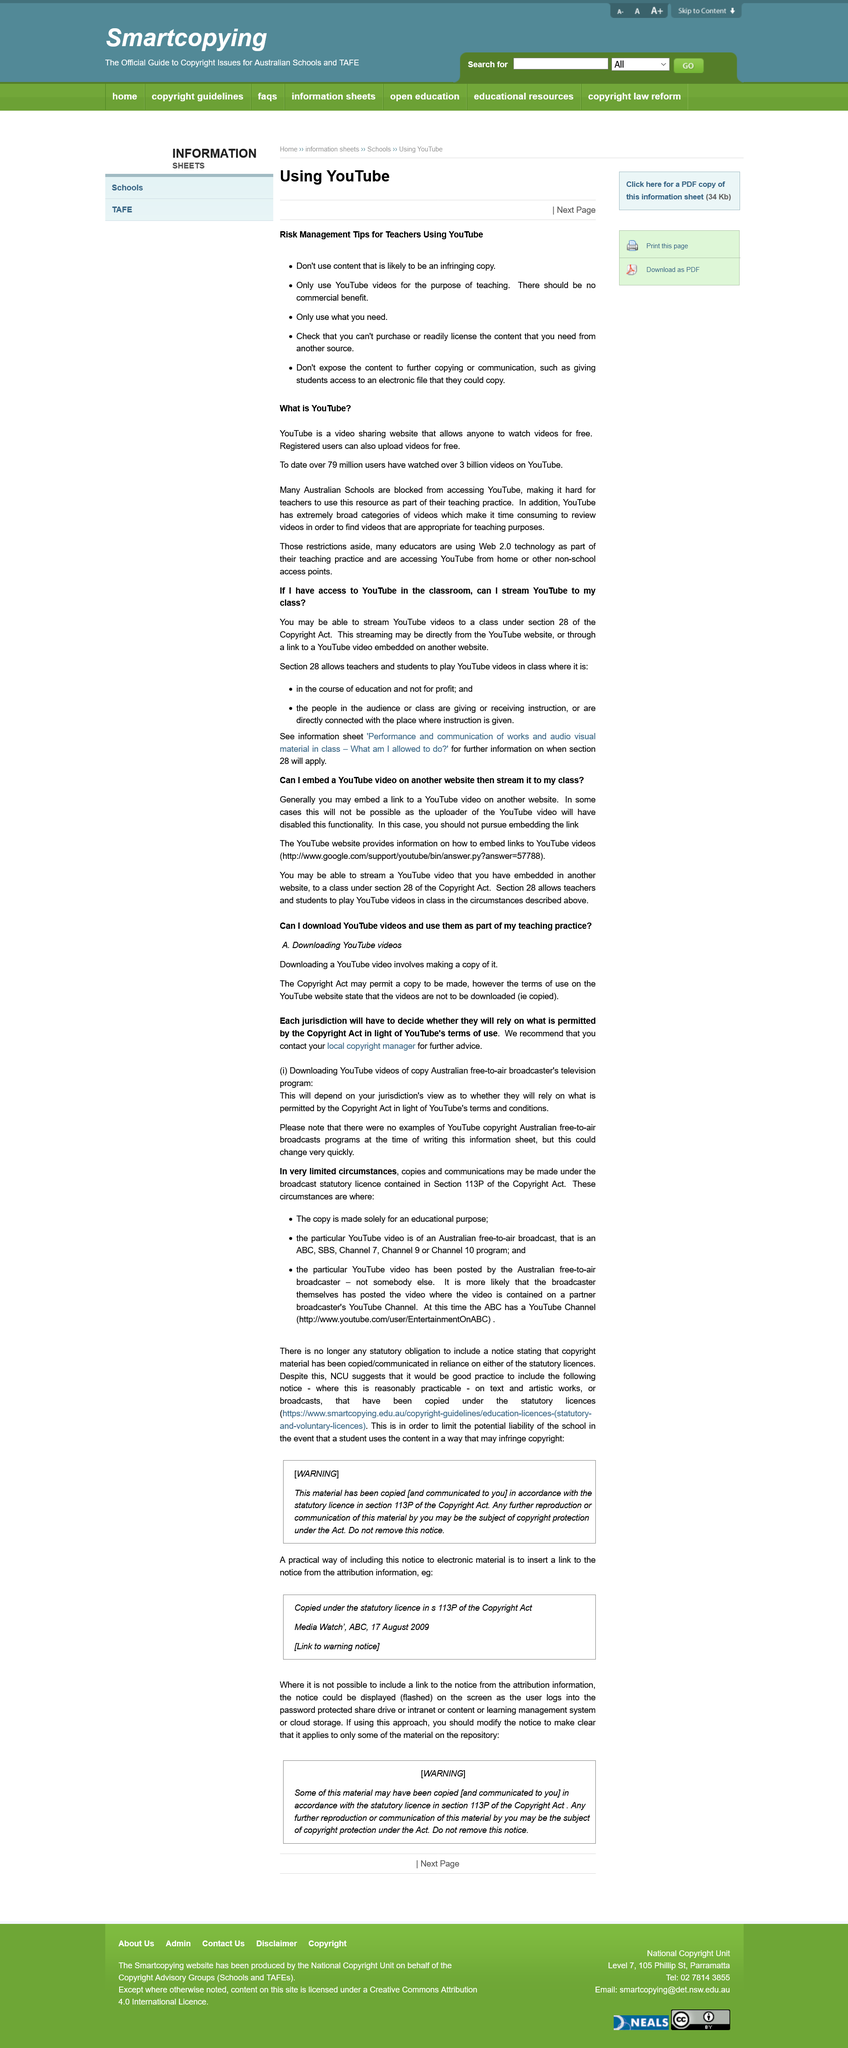Highlight a few significant elements in this photo. It is possible for a copywriter to create a copy of a video, provided that it is allowed in the terms and conditions. Downloading is not illegal if followed the steps. It is recommended to stream YouTube directly from the website or use an embedded video in a classroom setting to ensure optimal viewing quality and avoid technical difficulties. YouTube has 79 million active users. YouTube is a suitable website for watching videos. 